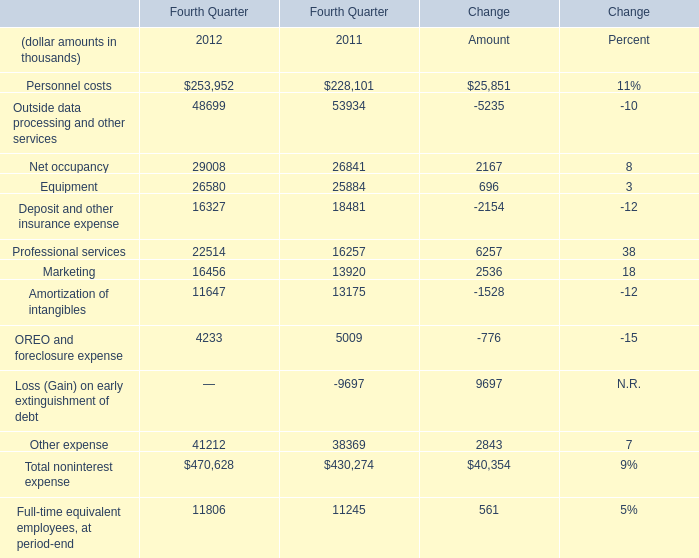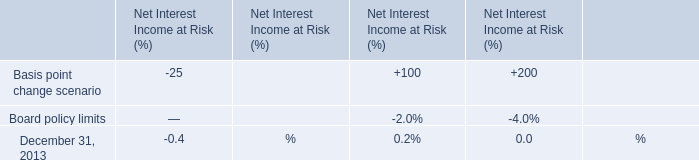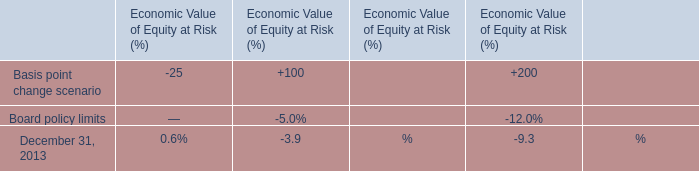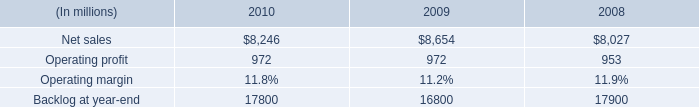What's the average of Net sales of 2009, and Amortization of intangibles of Fourth Quarter 2011 ? 
Computations: ((8654.0 + 13175.0) / 2)
Answer: 10914.5. 